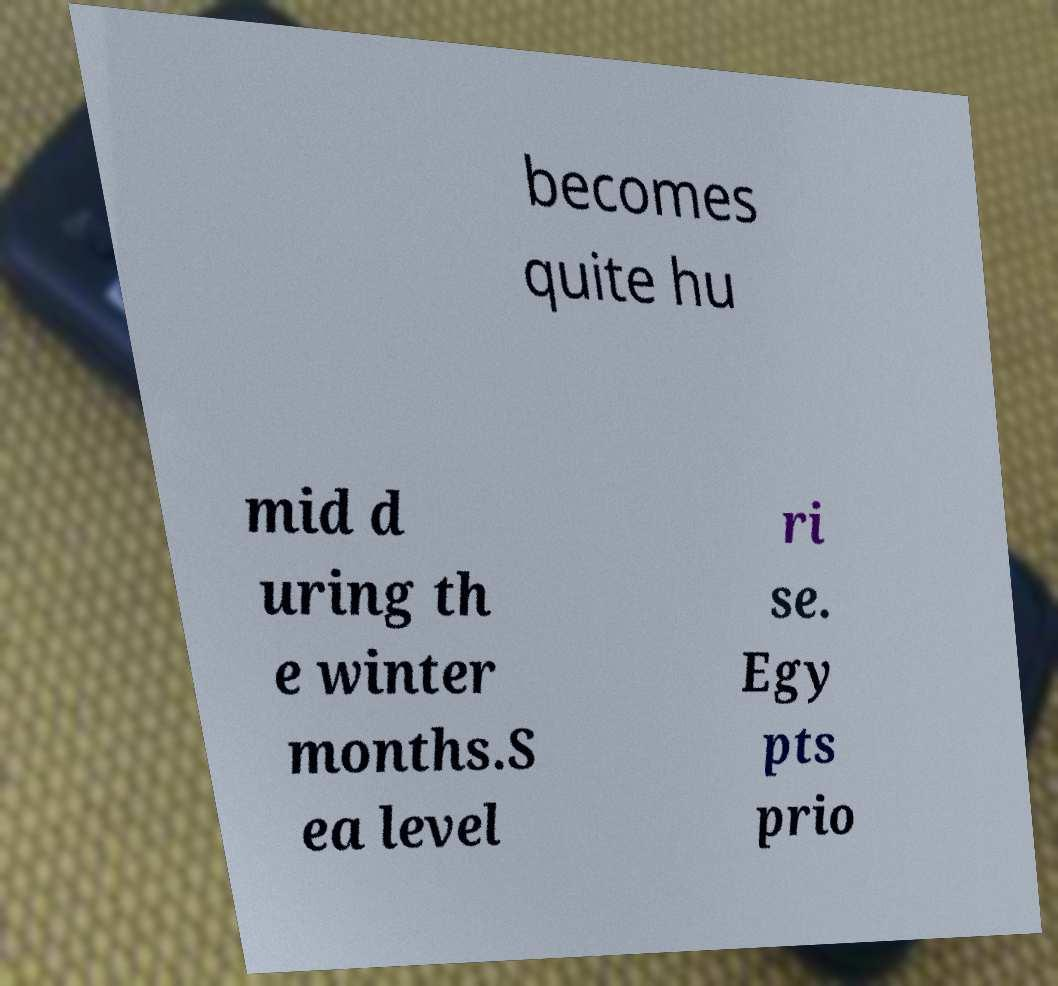Could you extract and type out the text from this image? becomes quite hu mid d uring th e winter months.S ea level ri se. Egy pts prio 